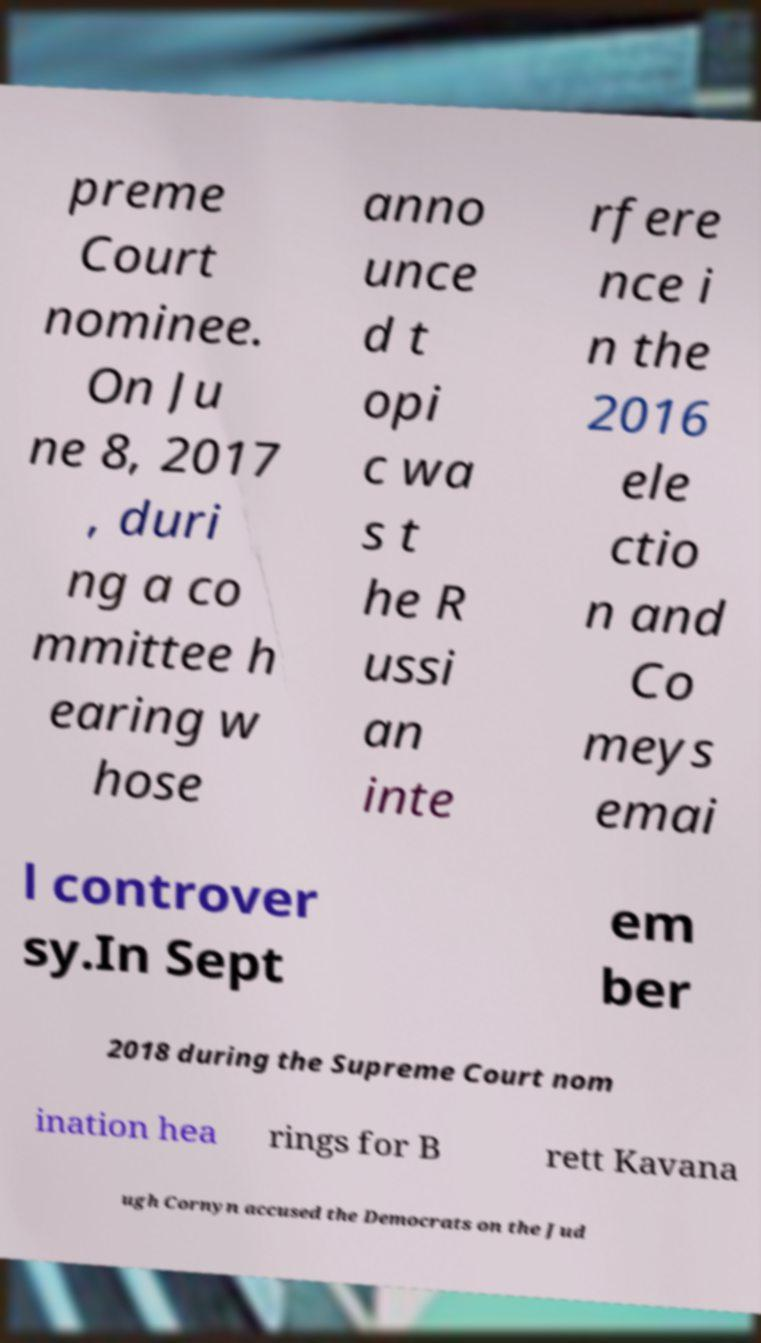Please read and relay the text visible in this image. What does it say? preme Court nominee. On Ju ne 8, 2017 , duri ng a co mmittee h earing w hose anno unce d t opi c wa s t he R ussi an inte rfere nce i n the 2016 ele ctio n and Co meys emai l controver sy.In Sept em ber 2018 during the Supreme Court nom ination hea rings for B rett Kavana ugh Cornyn accused the Democrats on the Jud 